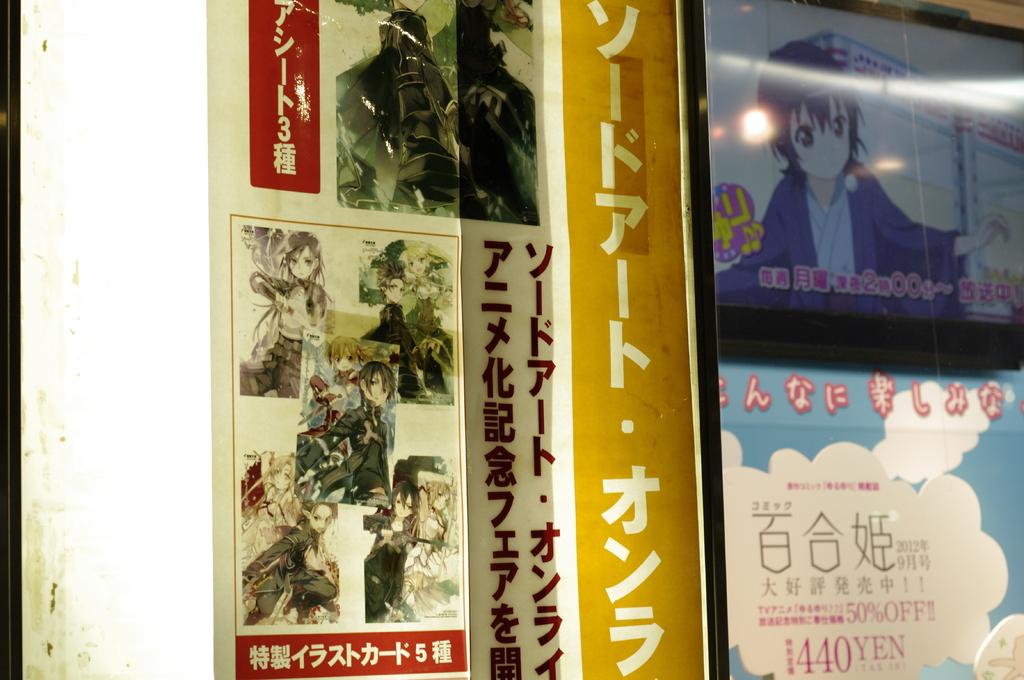How much money is it in the bottom right?
Keep it short and to the point. 440 yen. 